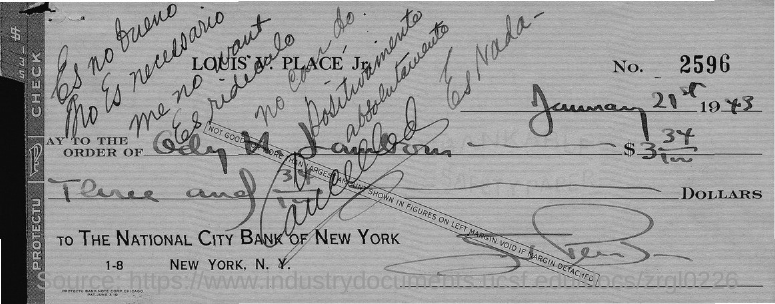Draw attention to some important aspects in this diagram. What is the number on the check? It is 2,596. The National City Bank of New York is mentioned. 